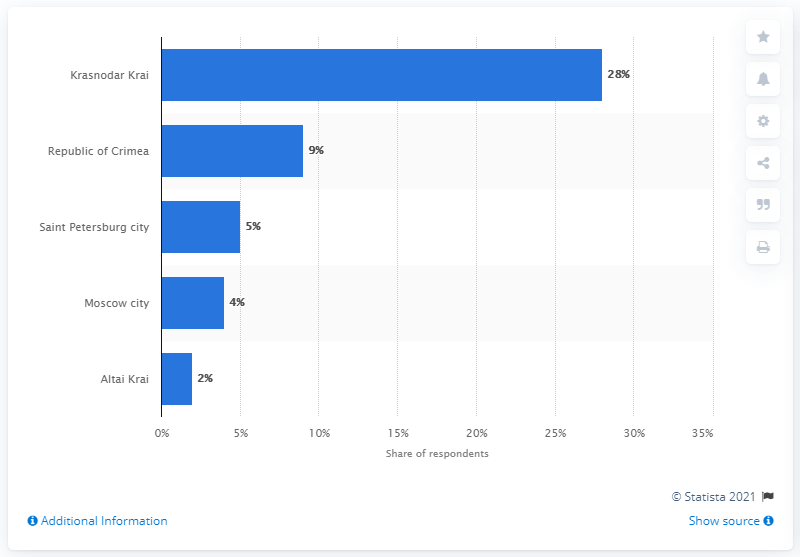Identify some key points in this picture. The Republic of Crimea was the second most visited region in Russia in 2020. 